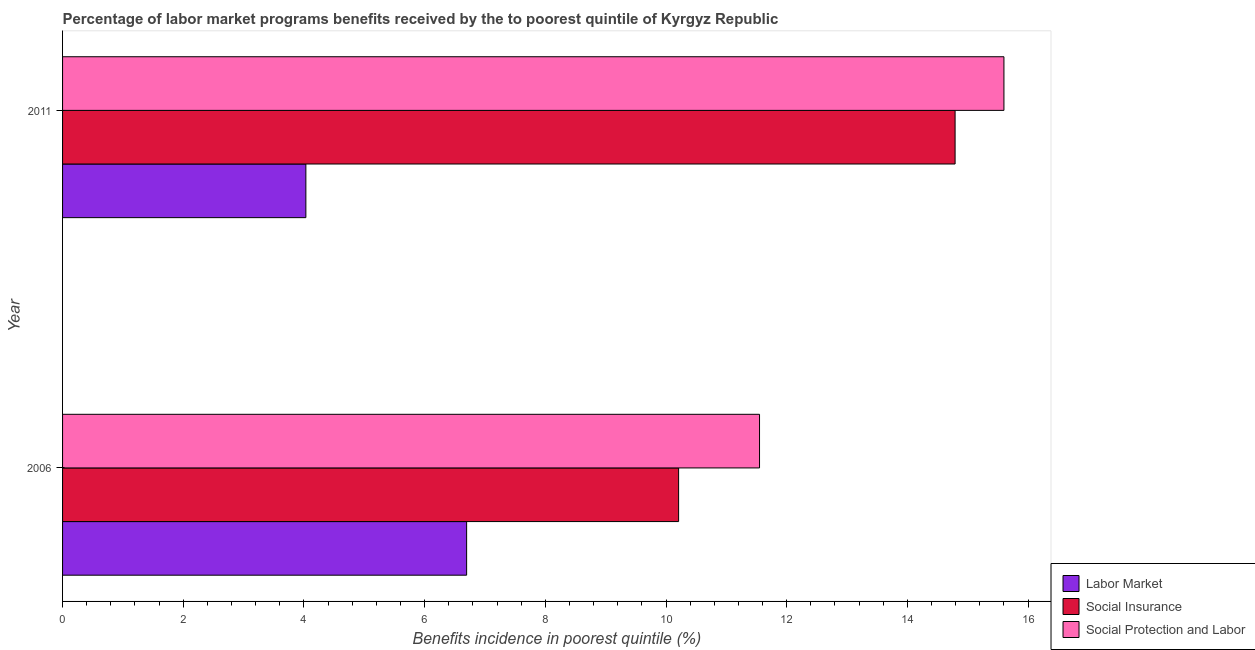Are the number of bars on each tick of the Y-axis equal?
Make the answer very short. Yes. How many bars are there on the 1st tick from the bottom?
Provide a succinct answer. 3. What is the label of the 2nd group of bars from the top?
Ensure brevity in your answer.  2006. In how many cases, is the number of bars for a given year not equal to the number of legend labels?
Your response must be concise. 0. What is the percentage of benefits received due to labor market programs in 2006?
Keep it short and to the point. 6.7. Across all years, what is the maximum percentage of benefits received due to labor market programs?
Provide a succinct answer. 6.7. Across all years, what is the minimum percentage of benefits received due to social protection programs?
Offer a terse response. 11.55. In which year was the percentage of benefits received due to labor market programs maximum?
Offer a very short reply. 2006. In which year was the percentage of benefits received due to labor market programs minimum?
Offer a terse response. 2011. What is the total percentage of benefits received due to social protection programs in the graph?
Provide a short and direct response. 27.15. What is the difference between the percentage of benefits received due to social insurance programs in 2006 and that in 2011?
Give a very brief answer. -4.58. What is the difference between the percentage of benefits received due to labor market programs in 2006 and the percentage of benefits received due to social insurance programs in 2011?
Keep it short and to the point. -8.09. What is the average percentage of benefits received due to social protection programs per year?
Offer a very short reply. 13.57. In the year 2006, what is the difference between the percentage of benefits received due to labor market programs and percentage of benefits received due to social protection programs?
Keep it short and to the point. -4.85. In how many years, is the percentage of benefits received due to labor market programs greater than 13.2 %?
Make the answer very short. 0. What is the ratio of the percentage of benefits received due to social insurance programs in 2006 to that in 2011?
Provide a short and direct response. 0.69. Is the difference between the percentage of benefits received due to social protection programs in 2006 and 2011 greater than the difference between the percentage of benefits received due to labor market programs in 2006 and 2011?
Ensure brevity in your answer.  No. What does the 1st bar from the top in 2011 represents?
Provide a succinct answer. Social Protection and Labor. What does the 2nd bar from the bottom in 2006 represents?
Provide a short and direct response. Social Insurance. How many bars are there?
Give a very brief answer. 6. What is the difference between two consecutive major ticks on the X-axis?
Provide a short and direct response. 2. What is the title of the graph?
Ensure brevity in your answer.  Percentage of labor market programs benefits received by the to poorest quintile of Kyrgyz Republic. Does "Coal" appear as one of the legend labels in the graph?
Give a very brief answer. No. What is the label or title of the X-axis?
Offer a terse response. Benefits incidence in poorest quintile (%). What is the label or title of the Y-axis?
Provide a succinct answer. Year. What is the Benefits incidence in poorest quintile (%) in Labor Market in 2006?
Your answer should be very brief. 6.7. What is the Benefits incidence in poorest quintile (%) in Social Insurance in 2006?
Offer a terse response. 10.21. What is the Benefits incidence in poorest quintile (%) of Social Protection and Labor in 2006?
Provide a succinct answer. 11.55. What is the Benefits incidence in poorest quintile (%) of Labor Market in 2011?
Give a very brief answer. 4.03. What is the Benefits incidence in poorest quintile (%) in Social Insurance in 2011?
Ensure brevity in your answer.  14.79. What is the Benefits incidence in poorest quintile (%) of Social Protection and Labor in 2011?
Ensure brevity in your answer.  15.6. Across all years, what is the maximum Benefits incidence in poorest quintile (%) of Labor Market?
Provide a short and direct response. 6.7. Across all years, what is the maximum Benefits incidence in poorest quintile (%) of Social Insurance?
Give a very brief answer. 14.79. Across all years, what is the maximum Benefits incidence in poorest quintile (%) of Social Protection and Labor?
Your response must be concise. 15.6. Across all years, what is the minimum Benefits incidence in poorest quintile (%) in Labor Market?
Your answer should be compact. 4.03. Across all years, what is the minimum Benefits incidence in poorest quintile (%) of Social Insurance?
Make the answer very short. 10.21. Across all years, what is the minimum Benefits incidence in poorest quintile (%) in Social Protection and Labor?
Your response must be concise. 11.55. What is the total Benefits incidence in poorest quintile (%) of Labor Market in the graph?
Offer a very short reply. 10.73. What is the total Benefits incidence in poorest quintile (%) in Social Insurance in the graph?
Provide a short and direct response. 25. What is the total Benefits incidence in poorest quintile (%) in Social Protection and Labor in the graph?
Keep it short and to the point. 27.15. What is the difference between the Benefits incidence in poorest quintile (%) in Labor Market in 2006 and that in 2011?
Offer a terse response. 2.66. What is the difference between the Benefits incidence in poorest quintile (%) in Social Insurance in 2006 and that in 2011?
Offer a terse response. -4.58. What is the difference between the Benefits incidence in poorest quintile (%) of Social Protection and Labor in 2006 and that in 2011?
Give a very brief answer. -4.05. What is the difference between the Benefits incidence in poorest quintile (%) of Labor Market in 2006 and the Benefits incidence in poorest quintile (%) of Social Insurance in 2011?
Provide a succinct answer. -8.09. What is the difference between the Benefits incidence in poorest quintile (%) of Labor Market in 2006 and the Benefits incidence in poorest quintile (%) of Social Protection and Labor in 2011?
Keep it short and to the point. -8.9. What is the difference between the Benefits incidence in poorest quintile (%) in Social Insurance in 2006 and the Benefits incidence in poorest quintile (%) in Social Protection and Labor in 2011?
Make the answer very short. -5.39. What is the average Benefits incidence in poorest quintile (%) in Labor Market per year?
Your answer should be very brief. 5.36. What is the average Benefits incidence in poorest quintile (%) in Social Insurance per year?
Keep it short and to the point. 12.5. What is the average Benefits incidence in poorest quintile (%) in Social Protection and Labor per year?
Your answer should be very brief. 13.57. In the year 2006, what is the difference between the Benefits incidence in poorest quintile (%) of Labor Market and Benefits incidence in poorest quintile (%) of Social Insurance?
Keep it short and to the point. -3.51. In the year 2006, what is the difference between the Benefits incidence in poorest quintile (%) of Labor Market and Benefits incidence in poorest quintile (%) of Social Protection and Labor?
Give a very brief answer. -4.85. In the year 2006, what is the difference between the Benefits incidence in poorest quintile (%) in Social Insurance and Benefits incidence in poorest quintile (%) in Social Protection and Labor?
Your answer should be compact. -1.34. In the year 2011, what is the difference between the Benefits incidence in poorest quintile (%) in Labor Market and Benefits incidence in poorest quintile (%) in Social Insurance?
Offer a terse response. -10.76. In the year 2011, what is the difference between the Benefits incidence in poorest quintile (%) in Labor Market and Benefits incidence in poorest quintile (%) in Social Protection and Labor?
Ensure brevity in your answer.  -11.57. In the year 2011, what is the difference between the Benefits incidence in poorest quintile (%) of Social Insurance and Benefits incidence in poorest quintile (%) of Social Protection and Labor?
Your answer should be very brief. -0.81. What is the ratio of the Benefits incidence in poorest quintile (%) in Labor Market in 2006 to that in 2011?
Provide a succinct answer. 1.66. What is the ratio of the Benefits incidence in poorest quintile (%) of Social Insurance in 2006 to that in 2011?
Offer a terse response. 0.69. What is the ratio of the Benefits incidence in poorest quintile (%) of Social Protection and Labor in 2006 to that in 2011?
Keep it short and to the point. 0.74. What is the difference between the highest and the second highest Benefits incidence in poorest quintile (%) in Labor Market?
Provide a succinct answer. 2.66. What is the difference between the highest and the second highest Benefits incidence in poorest quintile (%) in Social Insurance?
Provide a short and direct response. 4.58. What is the difference between the highest and the second highest Benefits incidence in poorest quintile (%) in Social Protection and Labor?
Your response must be concise. 4.05. What is the difference between the highest and the lowest Benefits incidence in poorest quintile (%) in Labor Market?
Your response must be concise. 2.66. What is the difference between the highest and the lowest Benefits incidence in poorest quintile (%) in Social Insurance?
Your response must be concise. 4.58. What is the difference between the highest and the lowest Benefits incidence in poorest quintile (%) of Social Protection and Labor?
Your answer should be very brief. 4.05. 